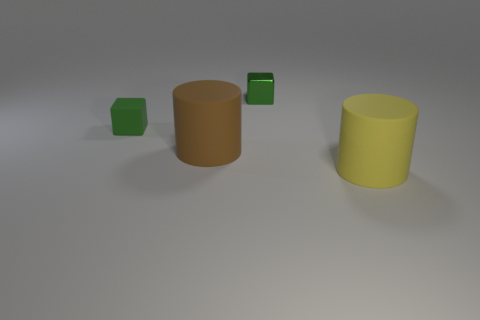Add 1 large cyan matte cylinders. How many objects exist? 5 Add 1 large brown objects. How many large brown objects exist? 2 Subtract 0 brown balls. How many objects are left? 4 Subtract all purple cylinders. Subtract all blue balls. How many cylinders are left? 2 Subtract all brown matte cylinders. Subtract all rubber things. How many objects are left? 0 Add 3 green metallic blocks. How many green metallic blocks are left? 4 